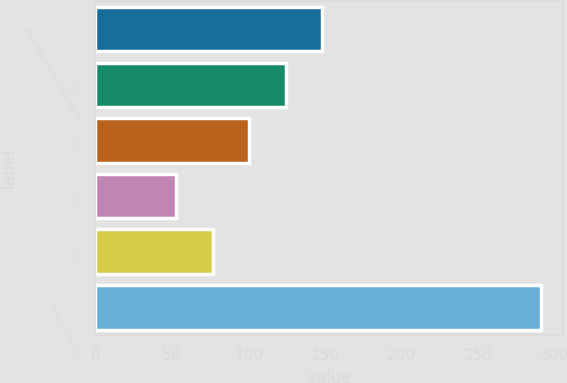Convert chart to OTSL. <chart><loc_0><loc_0><loc_500><loc_500><bar_chart><fcel>Expected benefit payments for<fcel>2016<fcel>2017<fcel>2018<fcel>2019<fcel>Years 2020-2024<nl><fcel>148.06<fcel>124.22<fcel>100.38<fcel>52.7<fcel>76.54<fcel>291.1<nl></chart> 